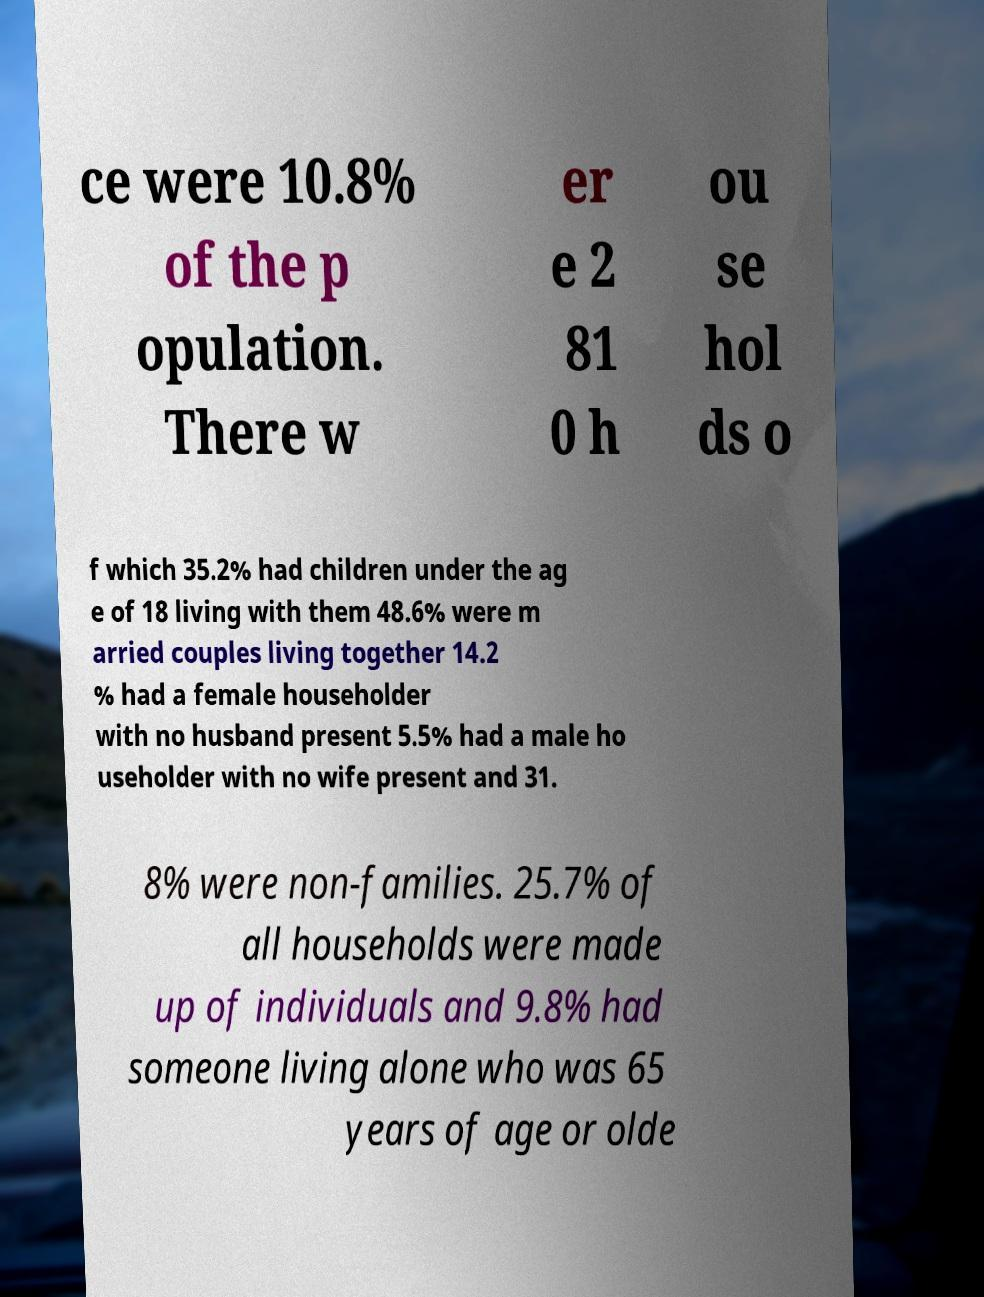Could you assist in decoding the text presented in this image and type it out clearly? ce were 10.8% of the p opulation. There w er e 2 81 0 h ou se hol ds o f which 35.2% had children under the ag e of 18 living with them 48.6% were m arried couples living together 14.2 % had a female householder with no husband present 5.5% had a male ho useholder with no wife present and 31. 8% were non-families. 25.7% of all households were made up of individuals and 9.8% had someone living alone who was 65 years of age or olde 